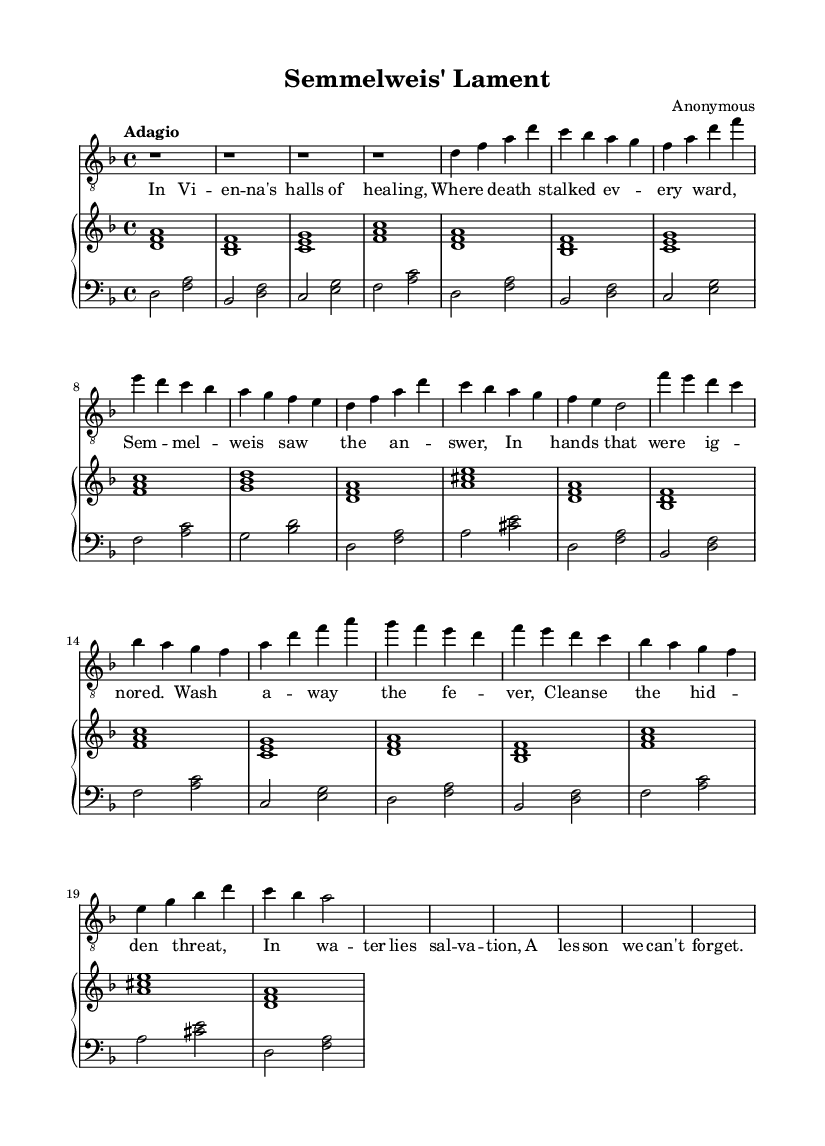What is the key signature of this music? The key signature is indicated by the direction that appears at the beginning of the piece, which is D minor. D minor has one flat (B flat).
Answer: D minor What is the time signature of this piece? The time signature is provided at the start of the sheet music, which shows that it is in four beats per measure. This is expressed as 4/4.
Answer: 4/4 What is the tempo marking for this piece? The tempo is noted at the beginning of the music, where it defines the speed as "Adagio," which means a slow tempo.
Answer: Adagio How many measures are in the introduction? By counting the rests and notes in the introductory section, which comprises four bars of rest (each represented as 'r1'), we determine that there are four measures.
Answer: 4 What is the emotional theme depicted in this aria? The lyrics, portraying Semmelweis's struggle and insight, evoke a sense of urgency and sadness related to medical neglect. The combination of text and music creates a dramatic atmosphere typical of romantic opera.
Answer: Sadness How many lines are there in the verse lyrics? The verse lyrics are structured into four lines, each corresponding to a musical phrase. Counting each complete phrase confirms this.
Answer: 4 What is the name of the historical figure depicted in this aria? The title and lyrics both reference Semmelweis, who is identified as a significant medical figure in the context of the aria.
Answer: Semmelweis 